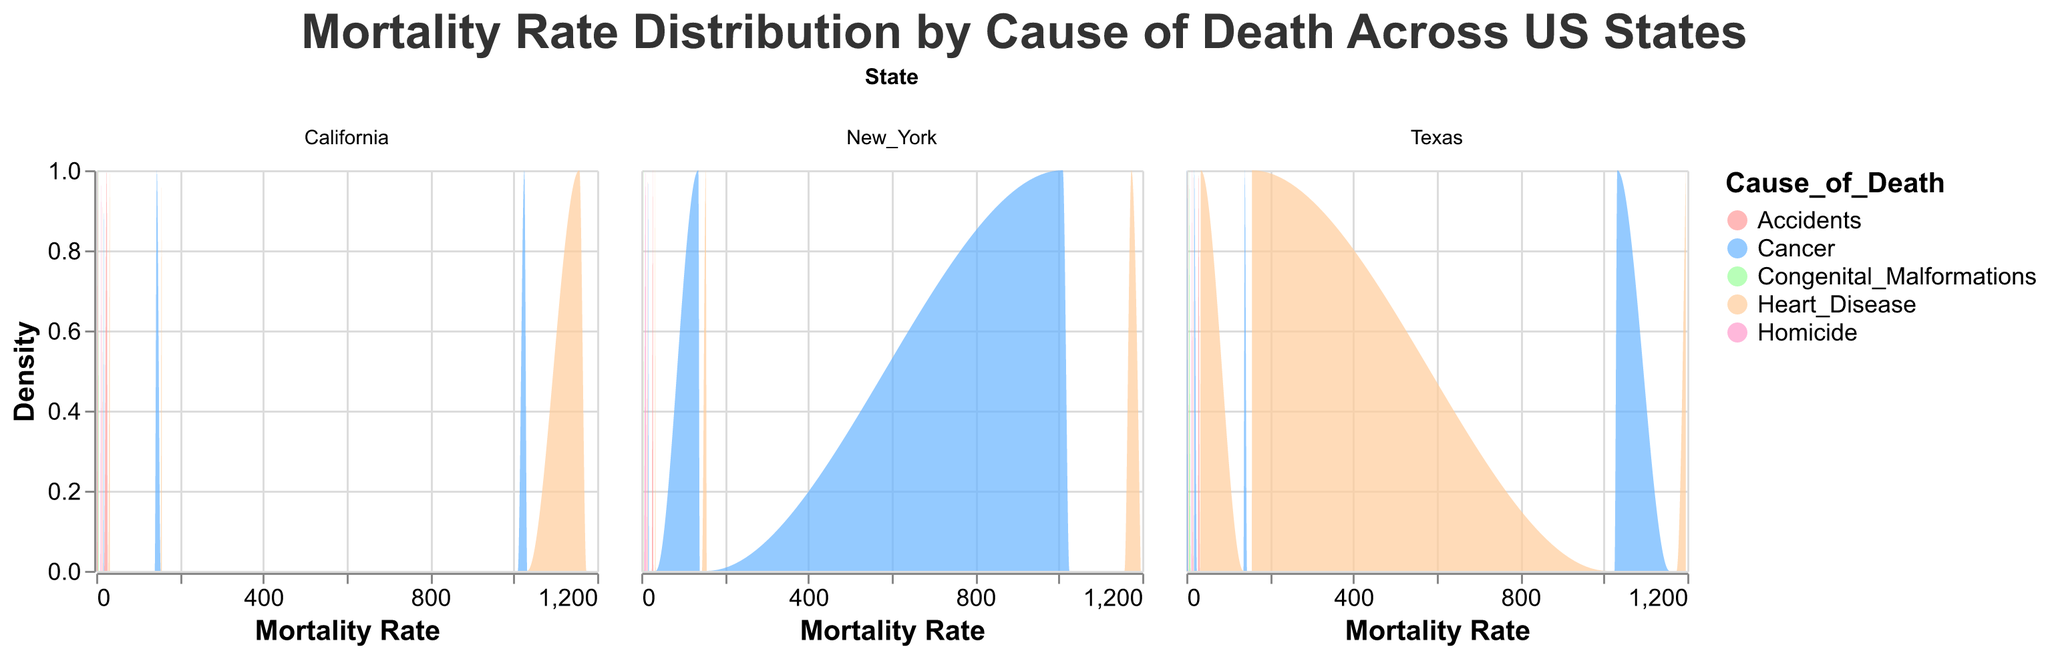What's the overall title of the figure? The title is typically located at the top of the figure and provides a general description of what the figure represents.
Answer: Mortality Rate Distribution by Cause of Death Across US States What is the color used to represent "Accidents" in the figure? The colors corresponding to each cause of death are specified in the legend. Identify the color associated with "Accidents".
Answer: #ff9999 Which US state has the highest mortality rate for heart disease in the age group 65+? The densities of mortality rates for different causes are visualized for each state. Locate the maximum density value for "Heart_Disease" in the age group 65+ for each state and compare them.
Answer: Texas How do the mortality rates for heart disease compare to cancer for age group 45-64 in California? To answer this, compare the density peaks or areas under the curves for "Heart_Disease" and "Cancer" within the 45-64 age group in California. Look for the values on the x-axis.
Answer: Heart disease has slightly higher densities than cancer Which age group in New York has the highest density for accidents? Examine the density plot for each age group in New York and identify where the peak density for "Accidents" occurs.
Answer: 15-24 In which state does congenital malformations have the least density for the age group 0-4? Compare the densities of "Congenital_Malformations" for the 0-4 age group across different states. Look for the plot with the lowest density curve.
Answer: California Are there any states where homicide rates for the age group 15-24 are higher than heart disease rates for the age group 25-44? Check the density plots for "Homicide" in the age group 15-24 and compare them against "Heart_Disease" in the age group 25-44 within the same state.
Answer: No What is the general trend in mortality rates for cancer as age increases in Texas? Trace the density plots for "Cancer" across different age groups in Texas and observe the trend in the peak values as age increases.
Answer: Increasing Which cause of death has the biggest density in California for age group 25-44? Check the density plot for all causes of death in the age group 25-44 in California and see which has the highest density peak.
Answer: Heart disease What is the mortality rate range represented on the x-axis of the density plots? The x-axis of the density plots displays the range of mortality rates. Identify the minimum and maximum values shown on this axis.
Answer: 0 to approximately 1200 